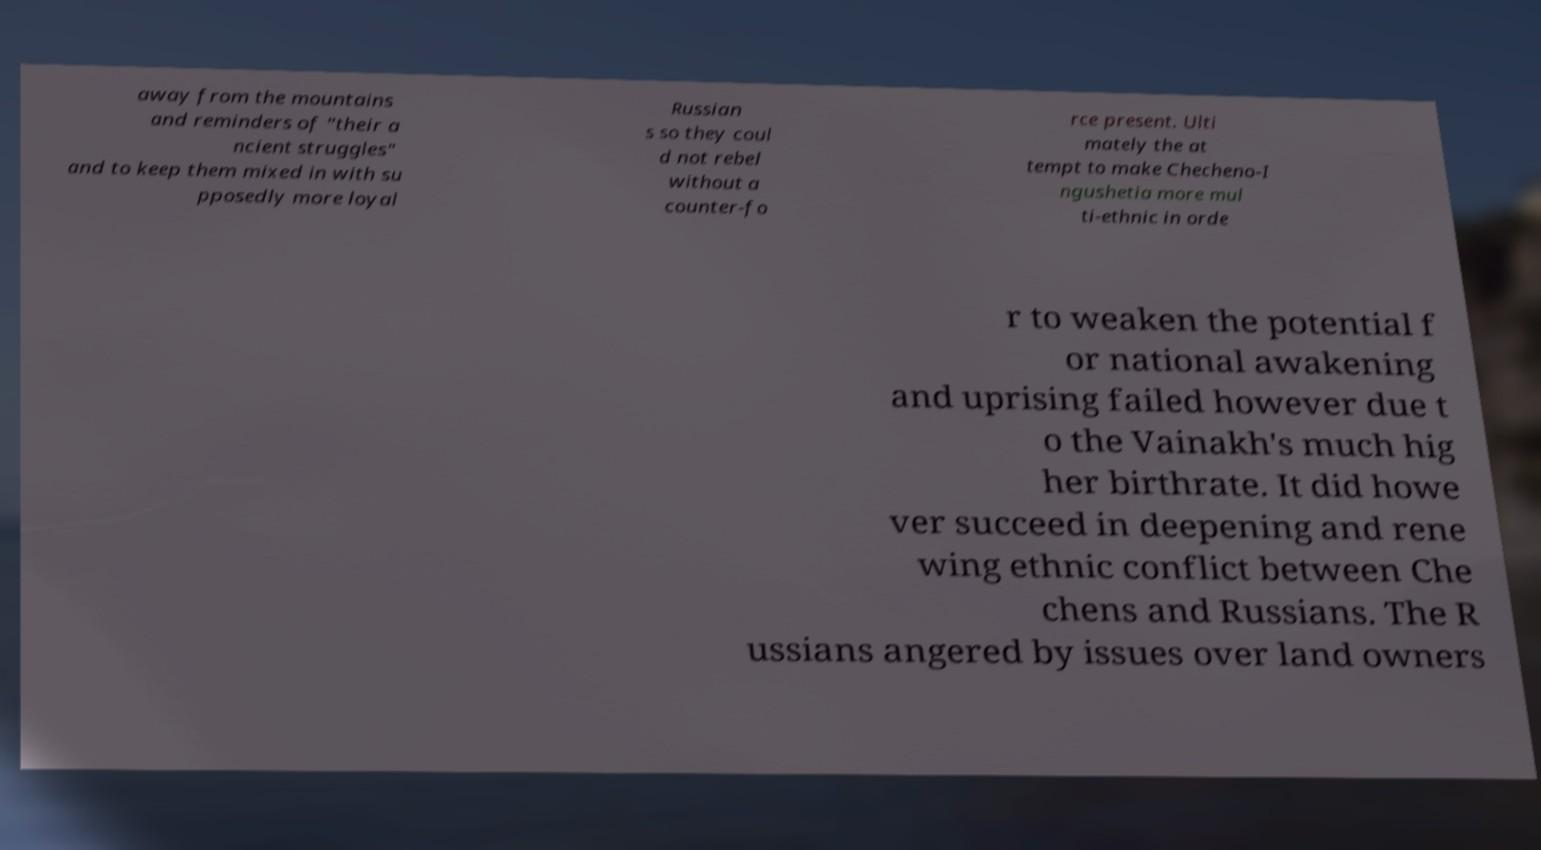Can you read and provide the text displayed in the image?This photo seems to have some interesting text. Can you extract and type it out for me? away from the mountains and reminders of "their a ncient struggles" and to keep them mixed in with su pposedly more loyal Russian s so they coul d not rebel without a counter-fo rce present. Ulti mately the at tempt to make Checheno-I ngushetia more mul ti-ethnic in orde r to weaken the potential f or national awakening and uprising failed however due t o the Vainakh's much hig her birthrate. It did howe ver succeed in deepening and rene wing ethnic conflict between Che chens and Russians. The R ussians angered by issues over land owners 